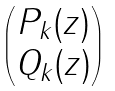<formula> <loc_0><loc_0><loc_500><loc_500>\begin{pmatrix} P _ { k } ( z ) \\ Q _ { k } ( z ) \end{pmatrix}</formula> 